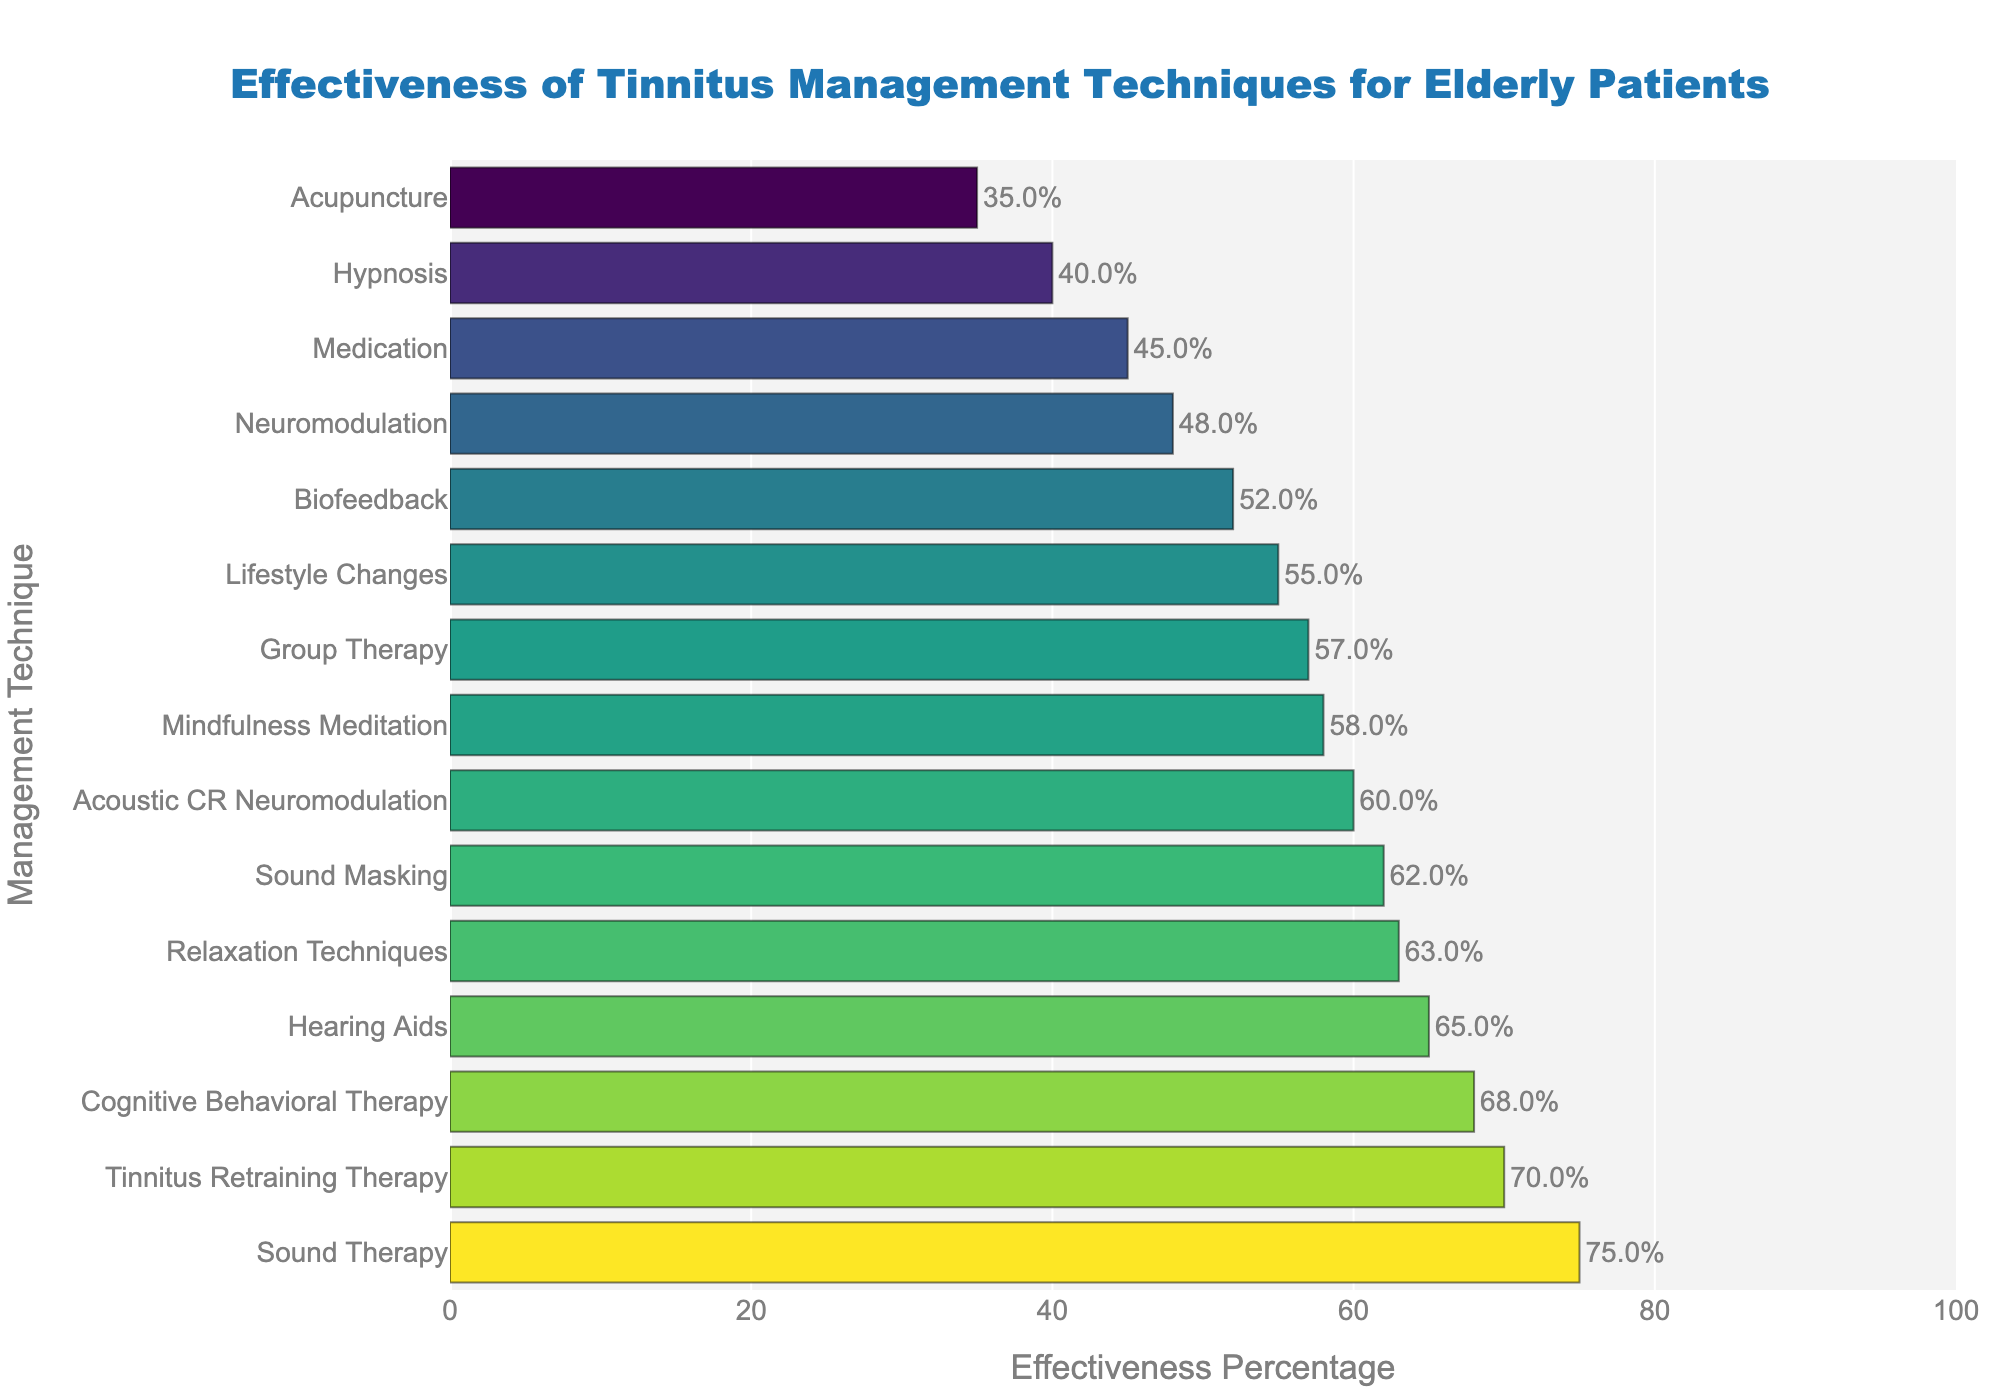What is the most effective tinnitus management technique for elderly patients? The most effective technique is the one with the highest effectiveness percentage. By examining the sorted bar chart, we see that Sound Therapy has the highest effectiveness percentage.
Answer: Sound Therapy Which technique has a lower effectiveness, Biofeedback or Neuromodulation? To compare the effectiveness, look for the effectiveness percentages of Biofeedback and Neuromodulation. Biofeedback has an effectiveness of 52%, while Neuromodulation has 48%.
Answer: Neuromodulation How many techniques have an effectiveness percentage greater than 60%? Count all the techniques with an effectiveness percentage exceeding 60%. According to the chart, those techniques are Sound Therapy, Cognitive Behavioral Therapy, Sound Masking, Tinnitus Retraining Therapy, and Relaxation Techniques, totaling 5 techniques.
Answer: 5 By how much does Sound Therapy's effectiveness percentage exceed the effectiveness percentage of Medication? Subtract the effectiveness percentage of Medication from that of Sound Therapy: 75% - 45% = 30%.
Answer: 30% What is the average effectiveness percentage of Cognitive Behavioral Therapy, Tinnitus Retraining Therapy, and Relaxation Techniques? Calculate the average by summing their effectiveness percentages and dividing by the number of techniques. (68% + 70% + 63%) / 3 = 67%.
Answer: 67 Are there any techniques with exactly 60% effectiveness? Visually inspect the chart to check if any bar aligns with the 60% mark. Acoustic CR Neuromodulation has exactly 60% effectiveness.
Answer: Acoustic CR Neuromodulation Which technique is more effective, Group Therapy or Hearing Aids? Compare the effectiveness percentages of Group Therapy (57%) and Hearing Aids (65%). Hearing Aids has a higher effectiveness percentage.
Answer: Hearing Aids What is the difference between the highest and lowest effectiveness percentages among the techniques? Identify the highest and lowest effectiveness percentages; highest is 75% (Sound Therapy), and lowest is 35% (Acupuncture). The difference is 75% - 35% = 40%.
Answer: 40% Which techniques have effectiveness percentages between 50% and 60%? Identify the techniques within the specified range. Based on the chart, Biofeedback (52%), Mindfulness Meditation (58%), Acoustic CR Neuromodulation (60%), Group Therapy (57%), and Lifestyle Changes (55%) fall within this range.
Answer: Biofeedback, Mindfulness Meditation, Acoustic CR Neuromodulation, Group Therapy, Lifestyle Changes 